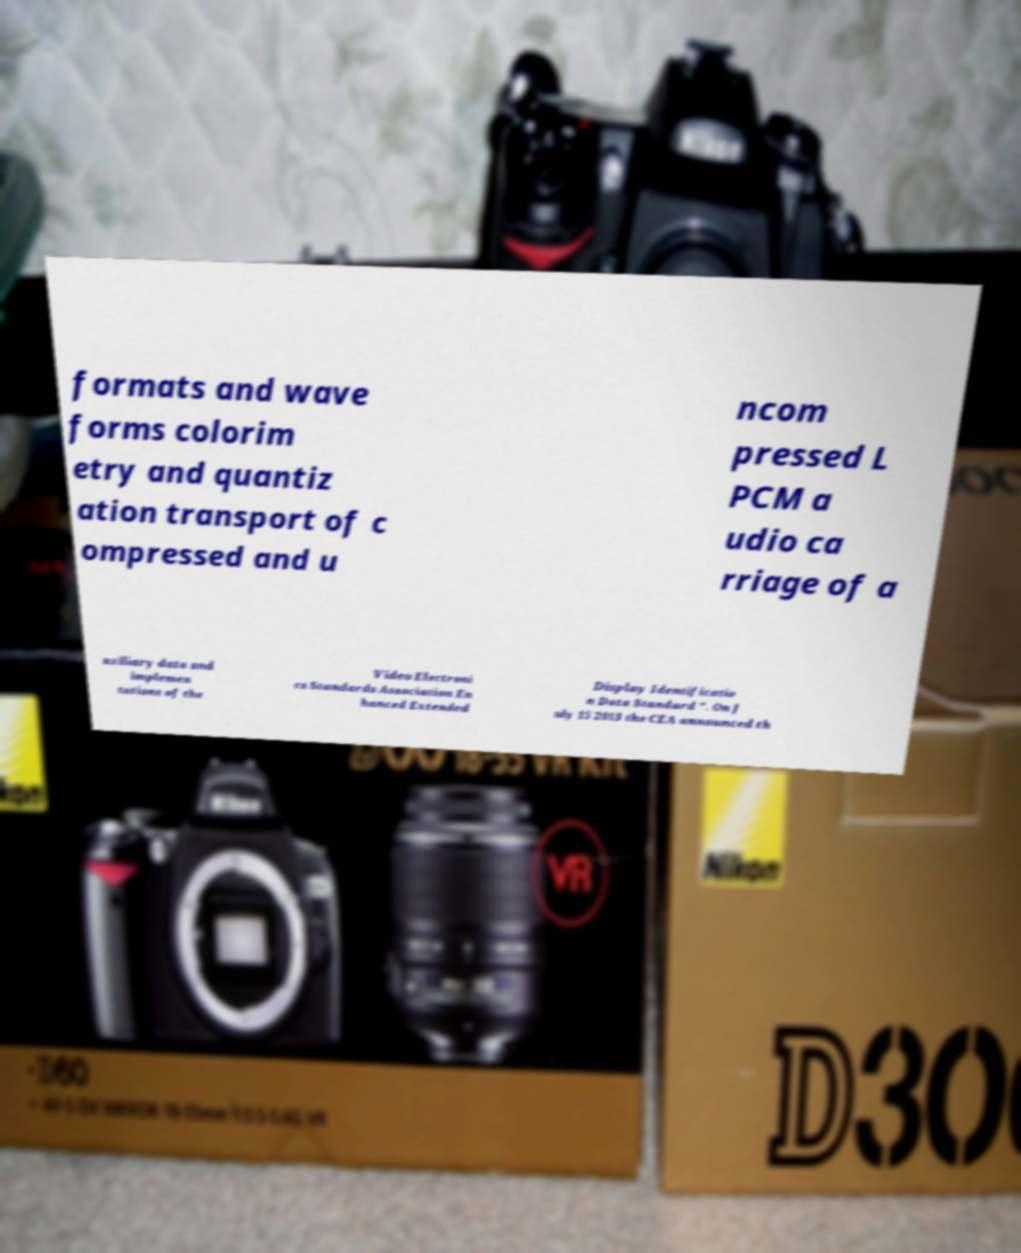Please identify and transcribe the text found in this image. formats and wave forms colorim etry and quantiz ation transport of c ompressed and u ncom pressed L PCM a udio ca rriage of a uxiliary data and implemen tations of the Video Electroni cs Standards Association En hanced Extended Display Identificatio n Data Standard ". On J uly 15 2013 the CEA announced th 